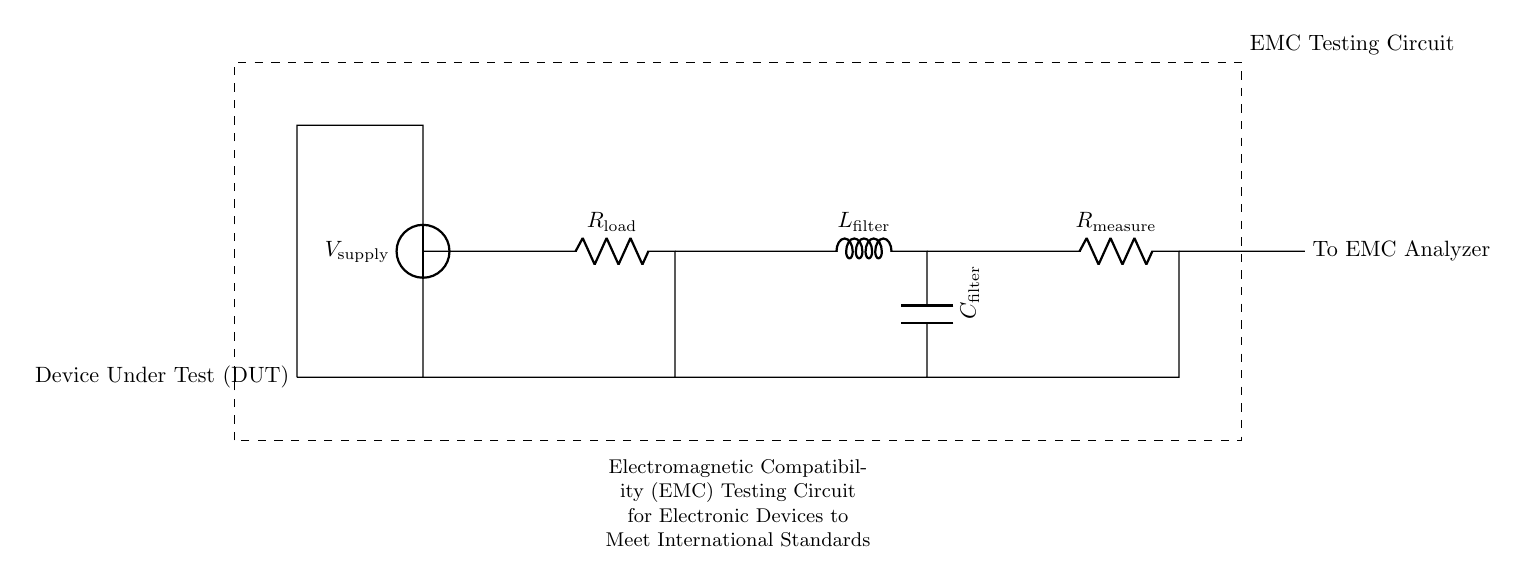What is the component labeled as R load? R load refers to the load resistor in the circuit, which is connected between two short lines at the center of the diagram, serving to represent the device's load during testing.
Answer: Load resistor What is the role of L filter in this EMC circuit? L filter, which is the inductor in the upper section of the circuit, helps to filter out high-frequency noise and provides better electromagnetic compatibility by preventing interference.
Answer: Filters noise What is the output measurement component? The output measurement component is R measure, located at the end of the circuit, which is used to measure the output for the electromagnetic compatibility analysis.
Answer: Measure resistor How many main components are in the circuit? The main components include the voltage source, load resistor, filter inductor, filter capacitor, and measurement resistor, totaling five components in the circuit.
Answer: Five What is the purpose of the dashed rectangle? The dashed rectangle indicates the boundary of the testing circuit, designating the area that encapsulates all components pertaining to EMC testing, which is crucial for regulatory considerations.
Answer: Testing boundary What does the device under test (DUT) signify in this circuit? The device under test signifies the electronic device that is being evaluated for electromagnetic compatibility, which is connected to the power supply and interactively tested in this setup.
Answer: Electronic device 